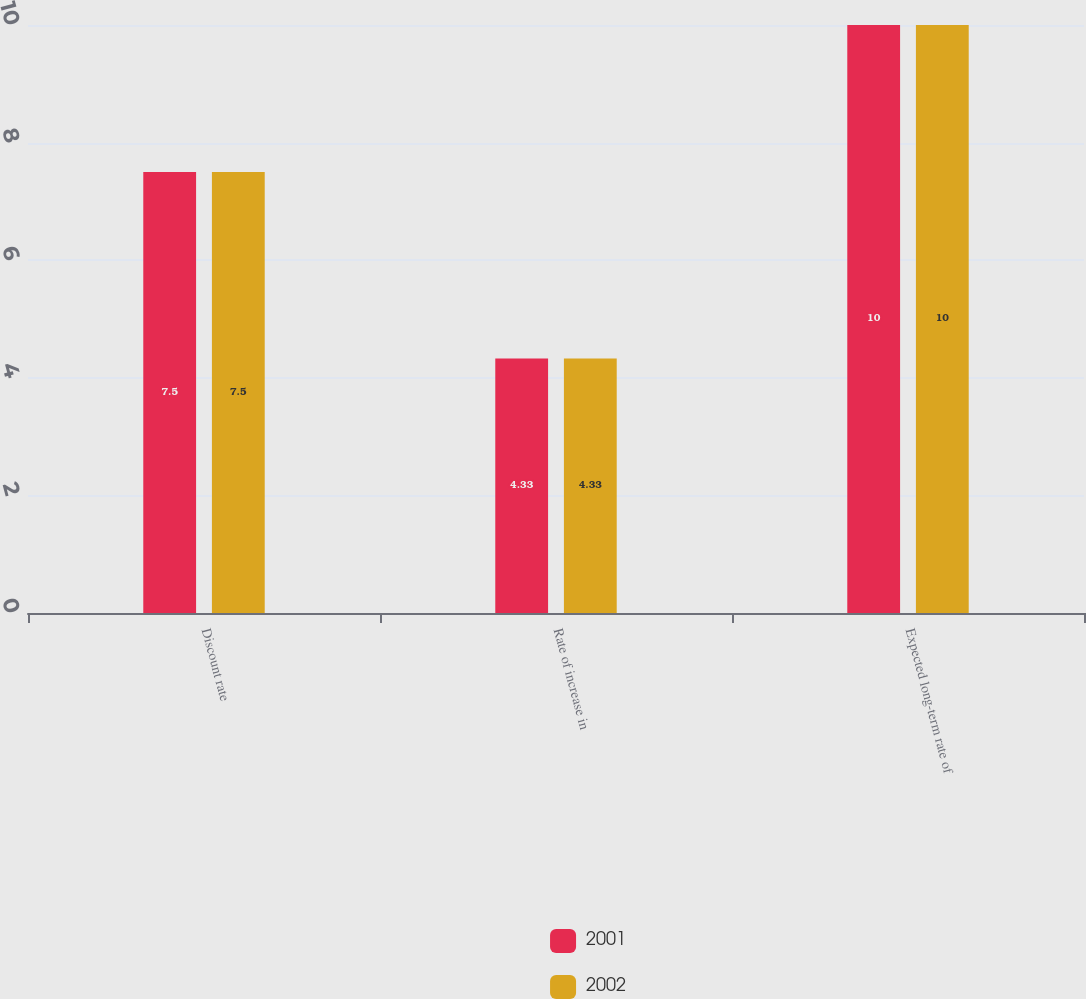<chart> <loc_0><loc_0><loc_500><loc_500><stacked_bar_chart><ecel><fcel>Discount rate<fcel>Rate of increase in<fcel>Expected long-term rate of<nl><fcel>2001<fcel>7.5<fcel>4.33<fcel>10<nl><fcel>2002<fcel>7.5<fcel>4.33<fcel>10<nl></chart> 